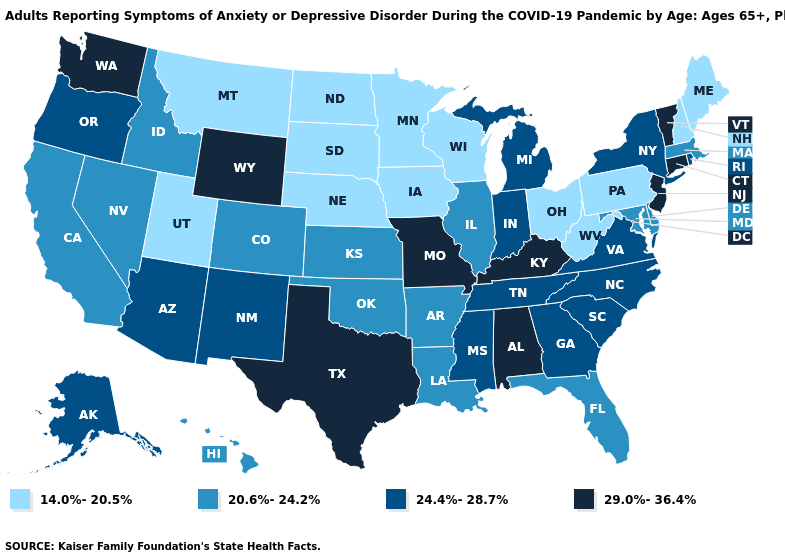Name the states that have a value in the range 29.0%-36.4%?
Be succinct. Alabama, Connecticut, Kentucky, Missouri, New Jersey, Texas, Vermont, Washington, Wyoming. What is the value of Idaho?
Answer briefly. 20.6%-24.2%. What is the value of South Dakota?
Concise answer only. 14.0%-20.5%. Does California have a lower value than Vermont?
Write a very short answer. Yes. What is the lowest value in the MidWest?
Short answer required. 14.0%-20.5%. How many symbols are there in the legend?
Quick response, please. 4. Is the legend a continuous bar?
Answer briefly. No. Is the legend a continuous bar?
Answer briefly. No. Name the states that have a value in the range 24.4%-28.7%?
Answer briefly. Alaska, Arizona, Georgia, Indiana, Michigan, Mississippi, New Mexico, New York, North Carolina, Oregon, Rhode Island, South Carolina, Tennessee, Virginia. Name the states that have a value in the range 24.4%-28.7%?
Give a very brief answer. Alaska, Arizona, Georgia, Indiana, Michigan, Mississippi, New Mexico, New York, North Carolina, Oregon, Rhode Island, South Carolina, Tennessee, Virginia. Name the states that have a value in the range 29.0%-36.4%?
Quick response, please. Alabama, Connecticut, Kentucky, Missouri, New Jersey, Texas, Vermont, Washington, Wyoming. What is the value of Missouri?
Be succinct. 29.0%-36.4%. Does Arizona have the same value as South Carolina?
Give a very brief answer. Yes. What is the lowest value in the USA?
Keep it brief. 14.0%-20.5%. Among the states that border Ohio , does West Virginia have the lowest value?
Be succinct. Yes. 